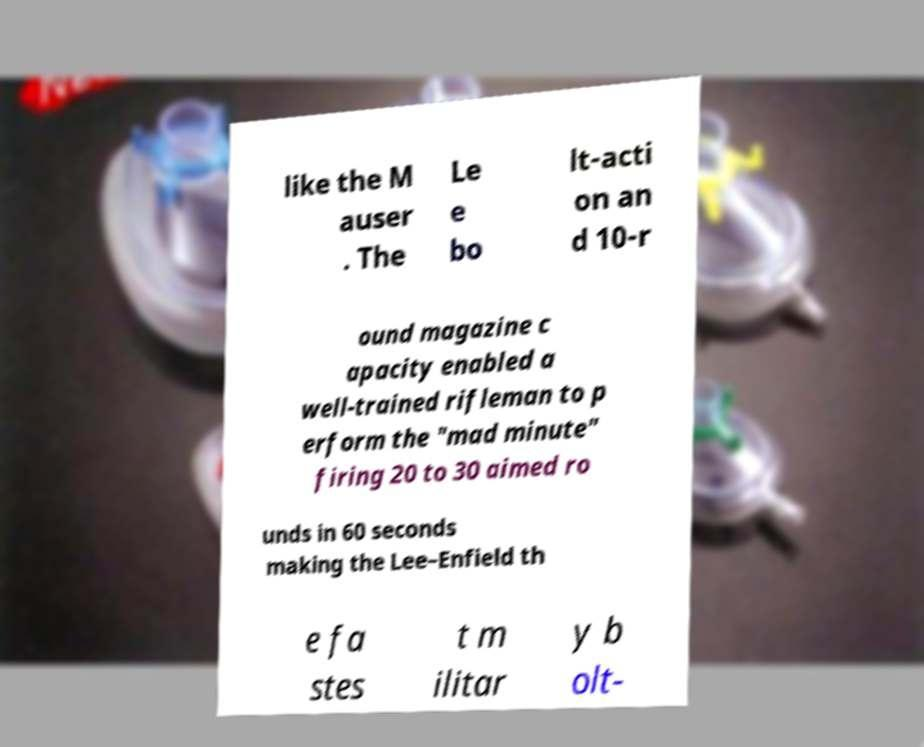Can you read and provide the text displayed in the image?This photo seems to have some interesting text. Can you extract and type it out for me? like the M auser . The Le e bo lt-acti on an d 10-r ound magazine c apacity enabled a well-trained rifleman to p erform the "mad minute" firing 20 to 30 aimed ro unds in 60 seconds making the Lee–Enfield th e fa stes t m ilitar y b olt- 